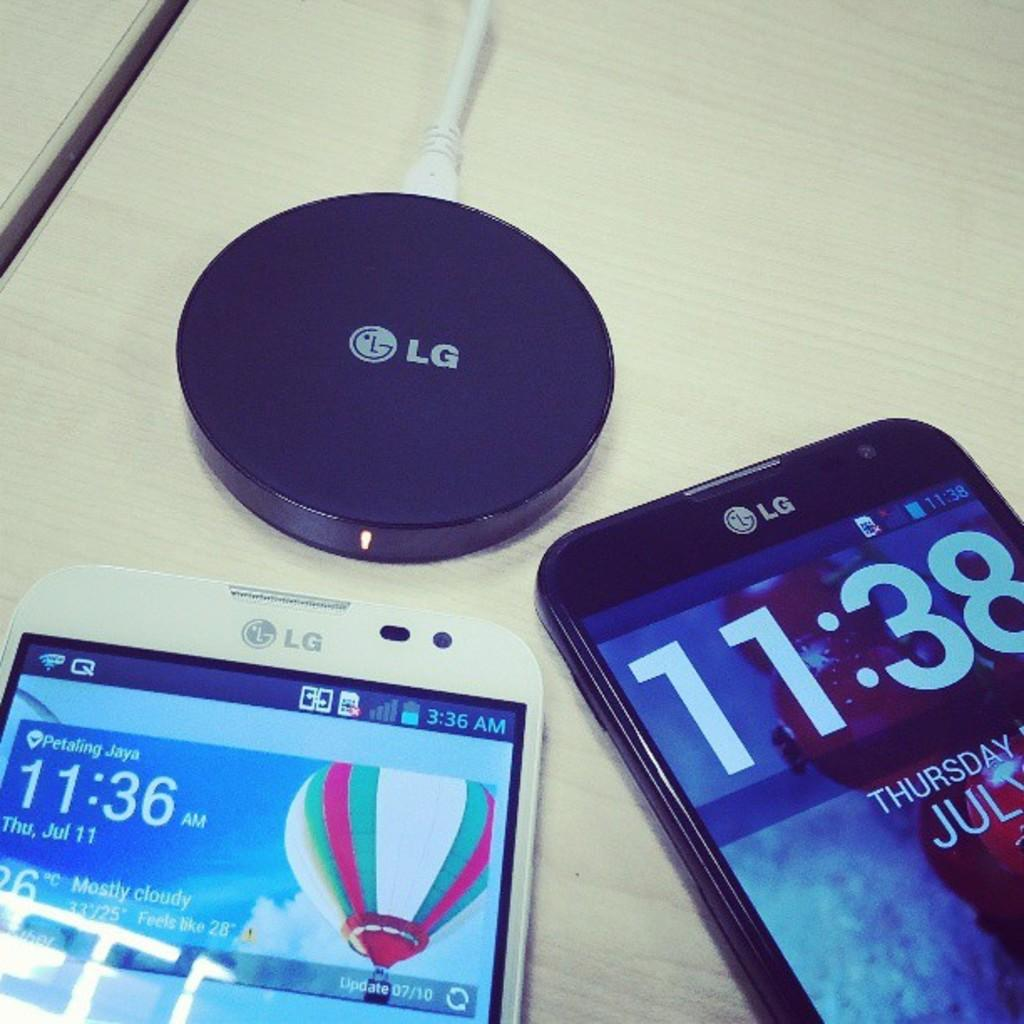<image>
Create a compact narrative representing the image presented. Laying on a table is a black and a white smart LG phones next to a charging station. 